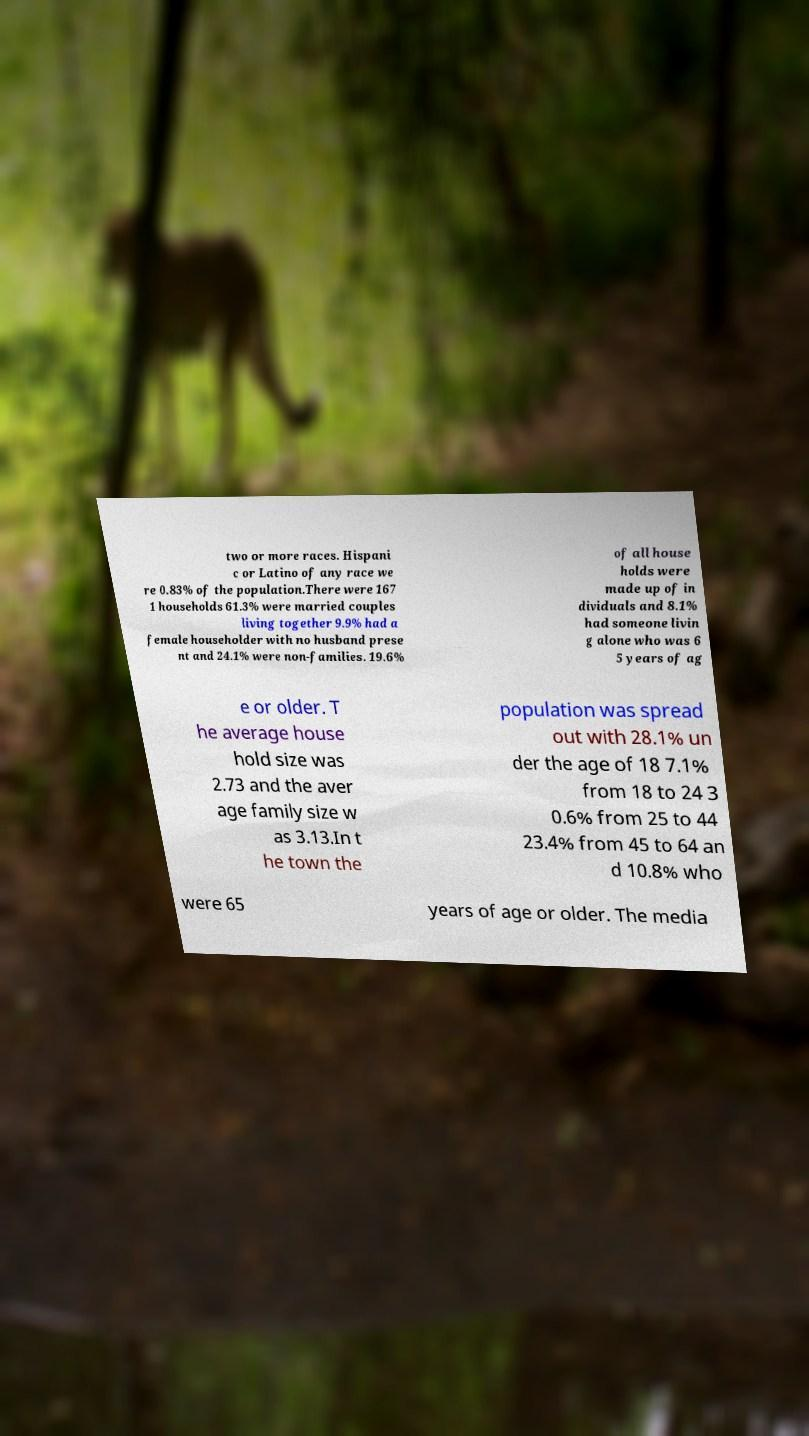I need the written content from this picture converted into text. Can you do that? two or more races. Hispani c or Latino of any race we re 0.83% of the population.There were 167 1 households 61.3% were married couples living together 9.9% had a female householder with no husband prese nt and 24.1% were non-families. 19.6% of all house holds were made up of in dividuals and 8.1% had someone livin g alone who was 6 5 years of ag e or older. T he average house hold size was 2.73 and the aver age family size w as 3.13.In t he town the population was spread out with 28.1% un der the age of 18 7.1% from 18 to 24 3 0.6% from 25 to 44 23.4% from 45 to 64 an d 10.8% who were 65 years of age or older. The media 